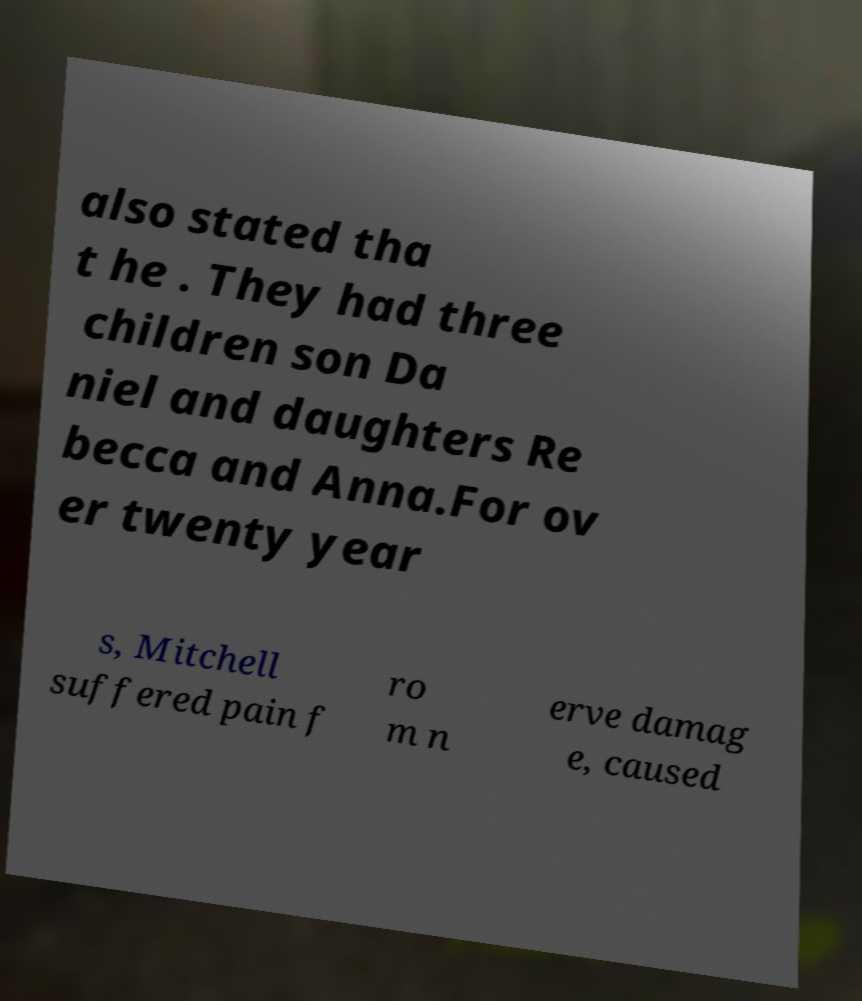Please read and relay the text visible in this image. What does it say? also stated tha t he . They had three children son Da niel and daughters Re becca and Anna.For ov er twenty year s, Mitchell suffered pain f ro m n erve damag e, caused 